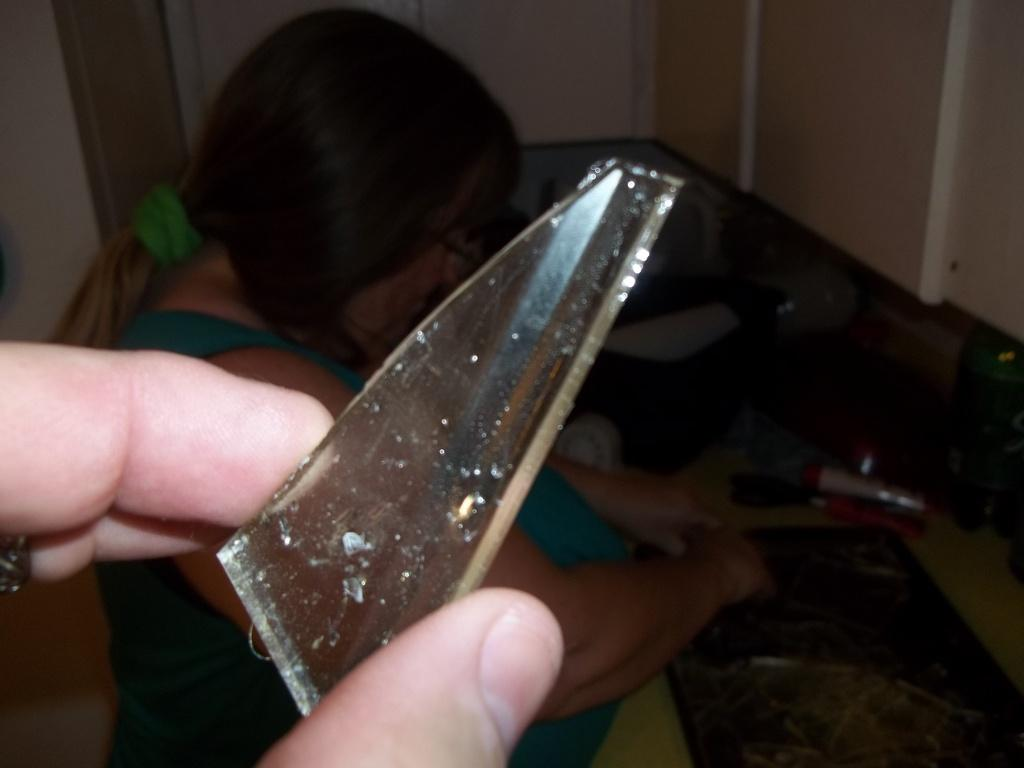How many people are in the image? There are two people in the image. What are the two persons doing in the image? The two persons are holding a piece of glass. What can be inferred about the setting of the image? There are objects inside the room, suggesting that the image was taken indoors. What type of meal is being prepared by the women in the image? There is no mention of women or a meal in the image; it only shows two people holding a piece of glass. 